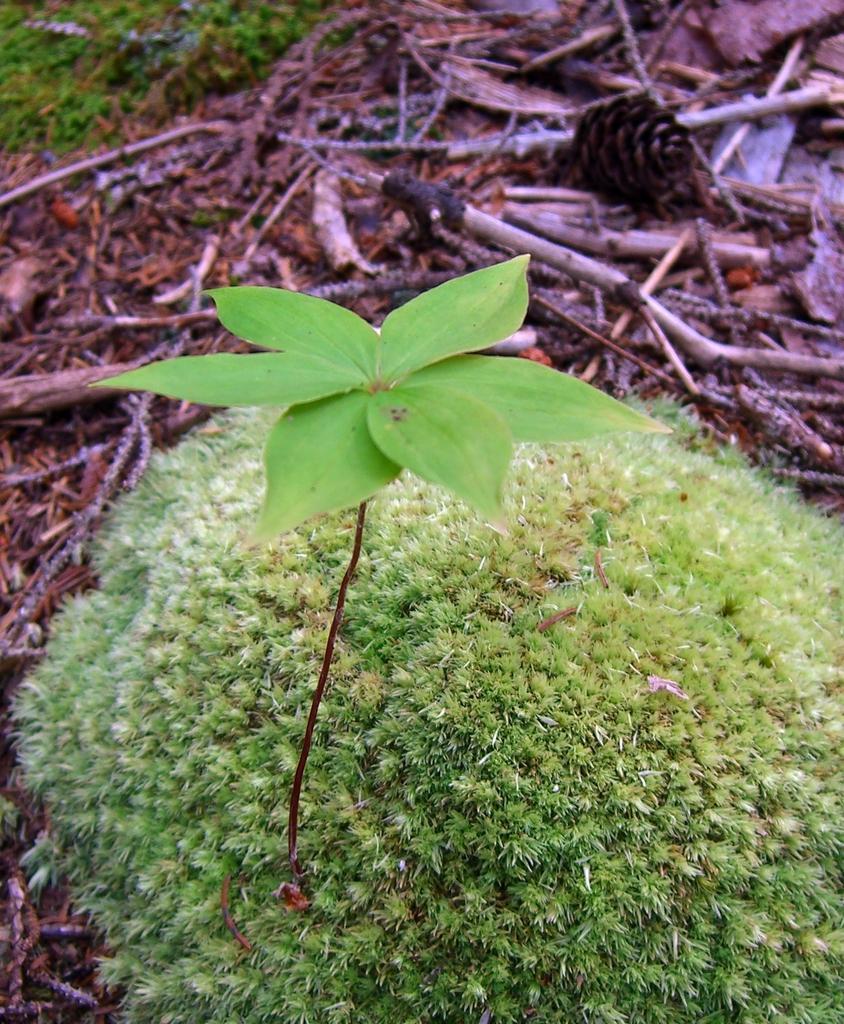How would you summarize this image in a sentence or two? In this image I can see a plant which is green in color and around it I can see few wooden logs and few leaves which are brown in color on the ground. 